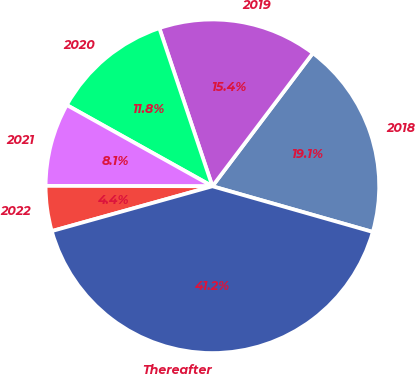Convert chart. <chart><loc_0><loc_0><loc_500><loc_500><pie_chart><fcel>2018<fcel>2019<fcel>2020<fcel>2021<fcel>2022<fcel>Thereafter<nl><fcel>19.13%<fcel>15.44%<fcel>11.75%<fcel>8.06%<fcel>4.37%<fcel>41.25%<nl></chart> 